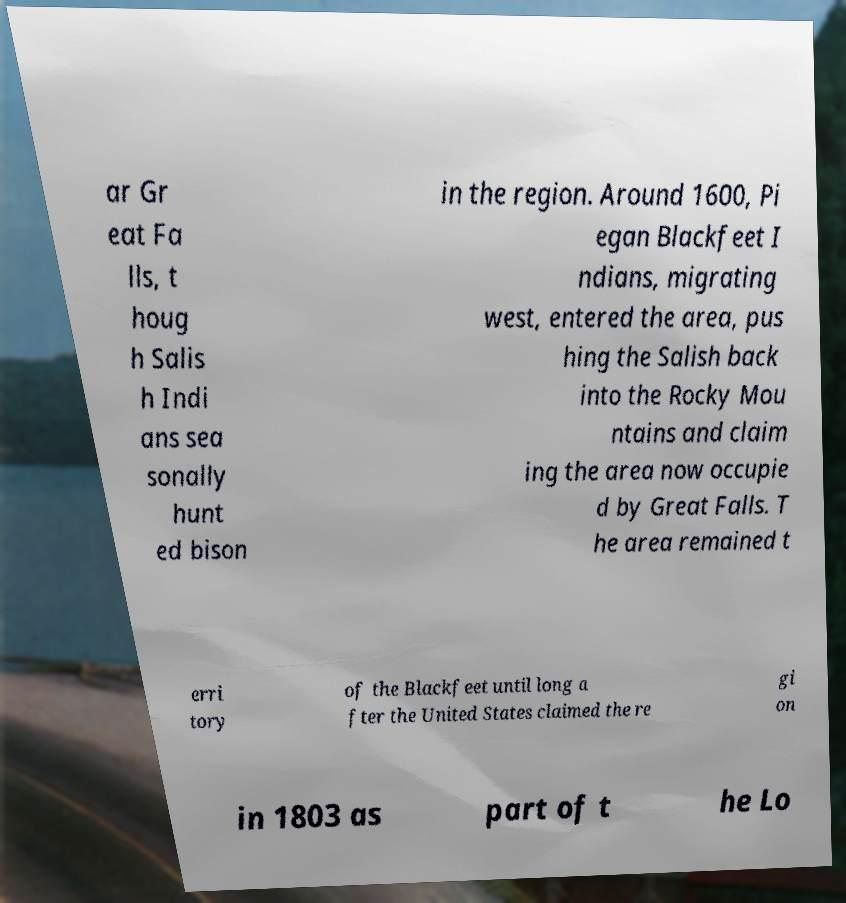Can you accurately transcribe the text from the provided image for me? ar Gr eat Fa lls, t houg h Salis h Indi ans sea sonally hunt ed bison in the region. Around 1600, Pi egan Blackfeet I ndians, migrating west, entered the area, pus hing the Salish back into the Rocky Mou ntains and claim ing the area now occupie d by Great Falls. T he area remained t erri tory of the Blackfeet until long a fter the United States claimed the re gi on in 1803 as part of t he Lo 